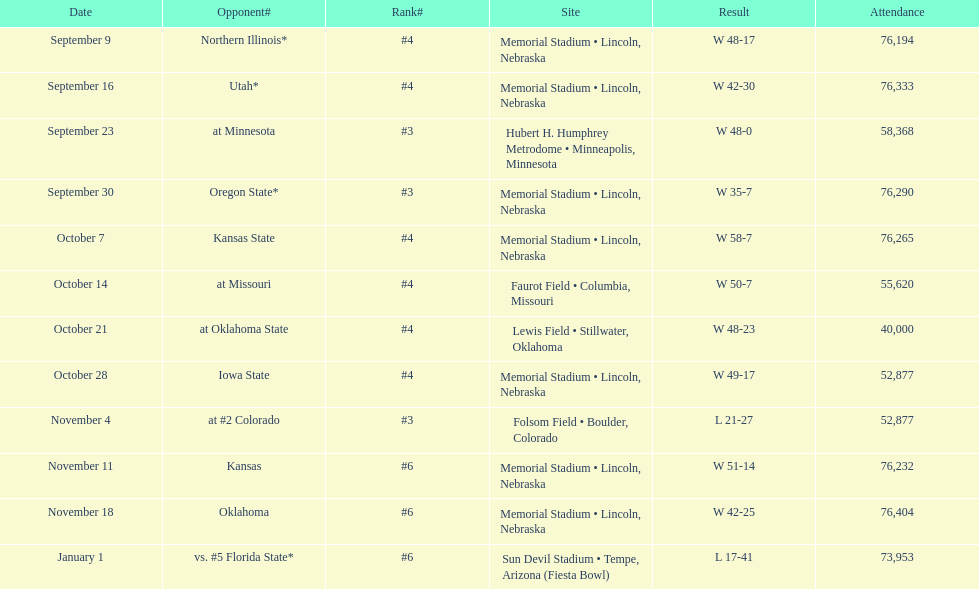I'm looking to parse the entire table for insights. Could you assist me with that? {'header': ['Date', 'Opponent#', 'Rank#', 'Site', 'Result', 'Attendance'], 'rows': [['September 9', 'Northern Illinois*', '#4', 'Memorial Stadium • Lincoln, Nebraska', 'W\xa048-17', '76,194'], ['September 16', 'Utah*', '#4', 'Memorial Stadium • Lincoln, Nebraska', 'W\xa042-30', '76,333'], ['September 23', 'at\xa0Minnesota', '#3', 'Hubert H. Humphrey Metrodome • Minneapolis, Minnesota', 'W\xa048-0', '58,368'], ['September 30', 'Oregon State*', '#3', 'Memorial Stadium • Lincoln, Nebraska', 'W\xa035-7', '76,290'], ['October 7', 'Kansas State', '#4', 'Memorial Stadium • Lincoln, Nebraska', 'W\xa058-7', '76,265'], ['October 14', 'at\xa0Missouri', '#4', 'Faurot Field • Columbia, Missouri', 'W\xa050-7', '55,620'], ['October 21', 'at\xa0Oklahoma State', '#4', 'Lewis Field • Stillwater, Oklahoma', 'W\xa048-23', '40,000'], ['October 28', 'Iowa State', '#4', 'Memorial Stadium • Lincoln, Nebraska', 'W\xa049-17', '52,877'], ['November 4', 'at\xa0#2\xa0Colorado', '#3', 'Folsom Field • Boulder, Colorado', 'L\xa021-27', '52,877'], ['November 11', 'Kansas', '#6', 'Memorial Stadium • Lincoln, Nebraska', 'W\xa051-14', '76,232'], ['November 18', 'Oklahoma', '#6', 'Memorial Stadium • Lincoln, Nebraska', 'W\xa042-25', '76,404'], ['January 1', 'vs.\xa0#5\xa0Florida State*', '#6', 'Sun Devil Stadium • Tempe, Arizona (Fiesta Bowl)', 'L\xa017-41', '73,953']]} How many times did their ranking stay at #5 or above in the games? 9. 